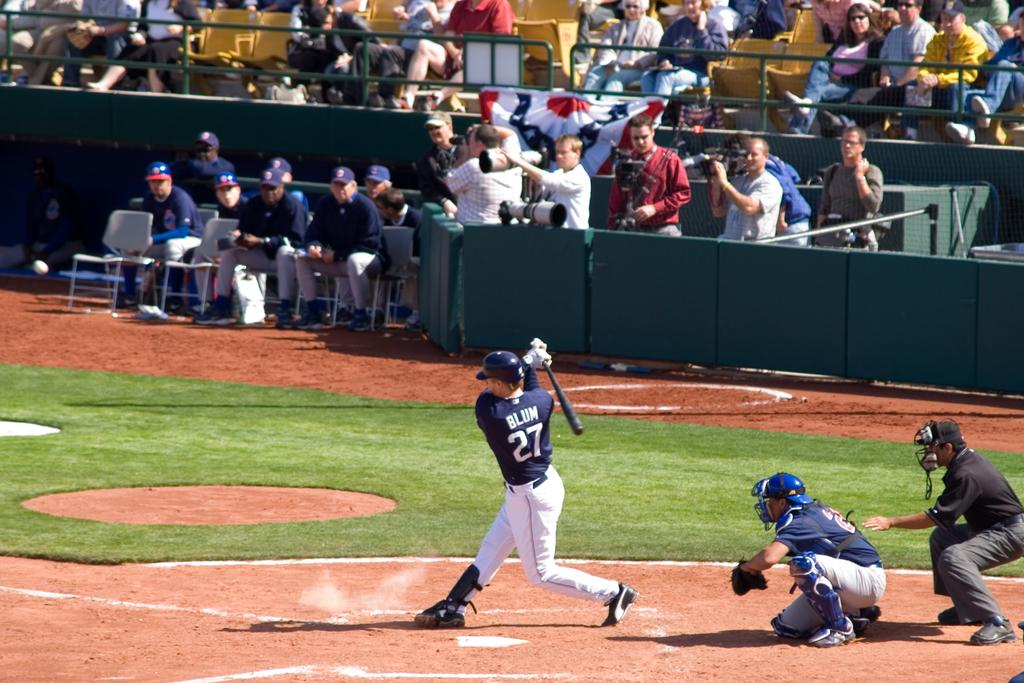<image>
Describe the image concisely. a baseball player on the field with the number 27 